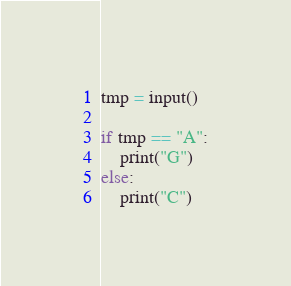<code> <loc_0><loc_0><loc_500><loc_500><_Python_>tmp = input()

if tmp == "A":
    print("G")
else:
    print("C")</code> 